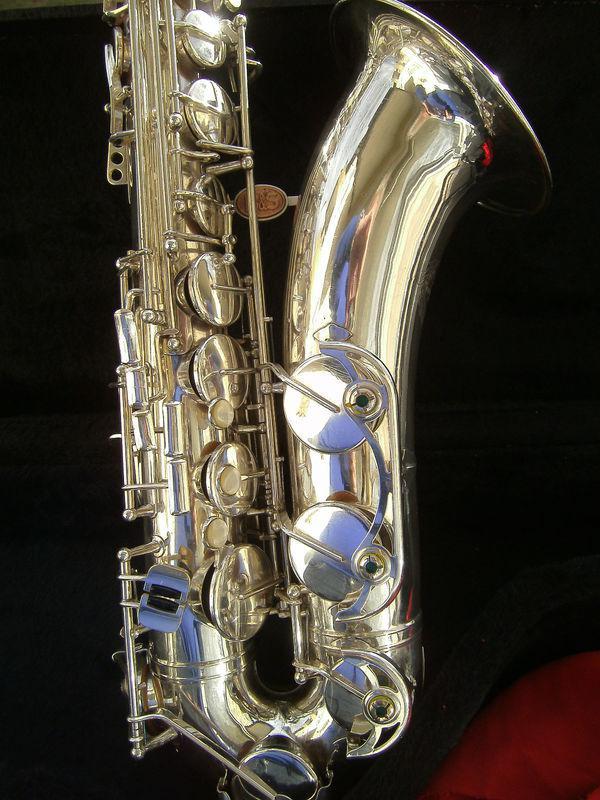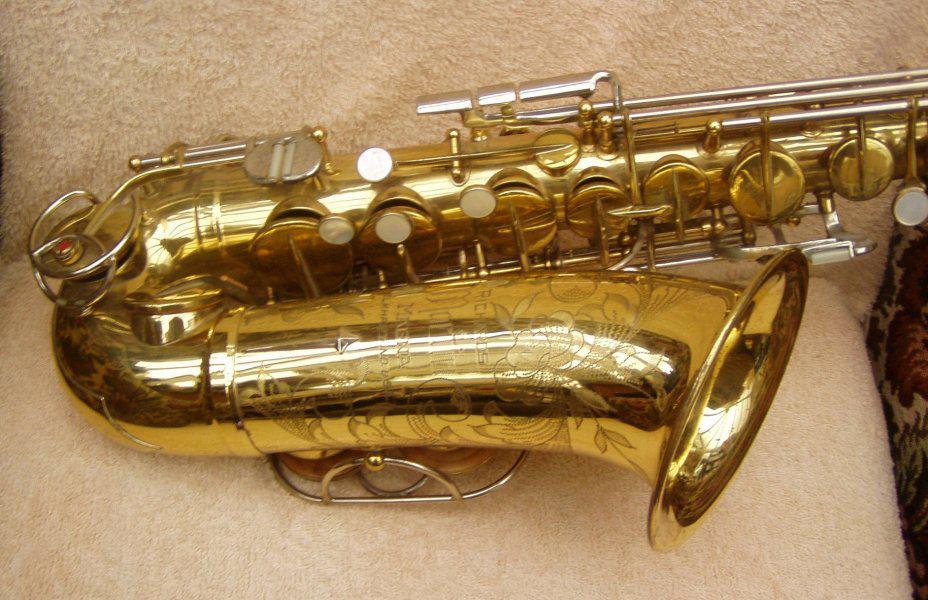The first image is the image on the left, the second image is the image on the right. Analyze the images presented: Is the assertion "The bell ends of two saxophones in different colors are lying horizontally, pointed toward the same direction." valid? Answer yes or no. No. 